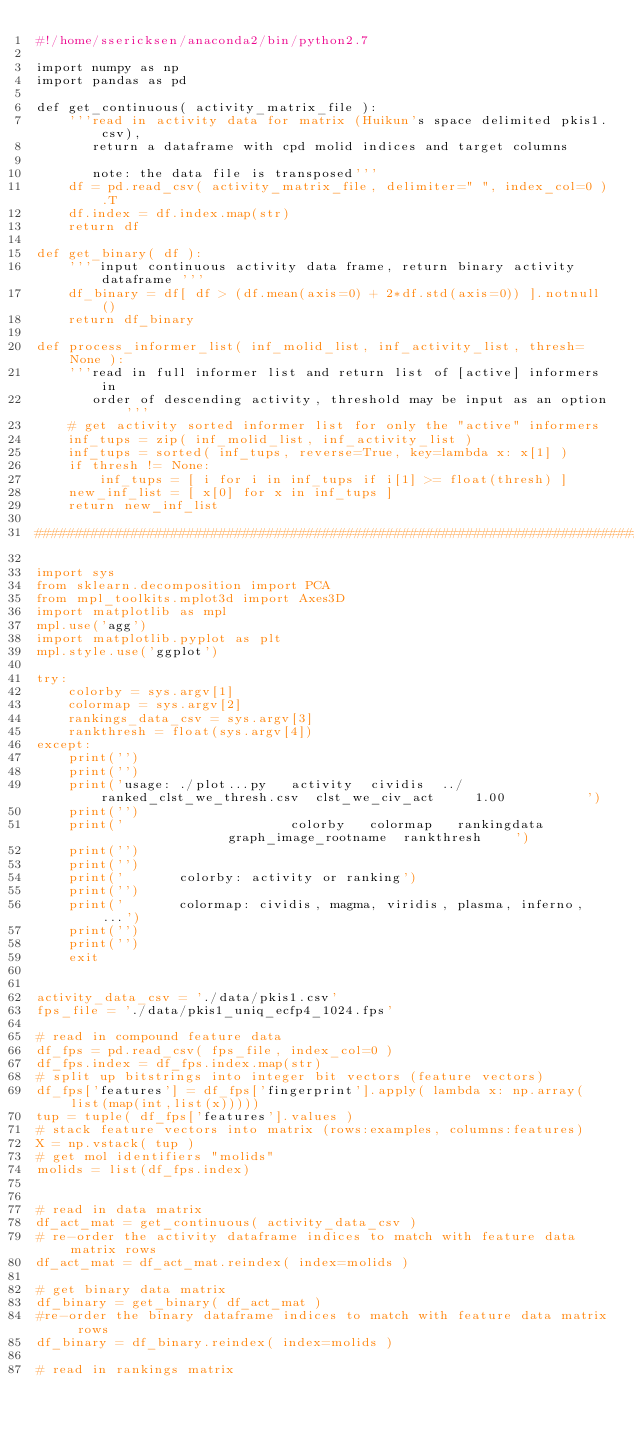Convert code to text. <code><loc_0><loc_0><loc_500><loc_500><_Python_>#!/home/ssericksen/anaconda2/bin/python2.7

import numpy as np
import pandas as pd

def get_continuous( activity_matrix_file ):
    '''read in activity data for matrix (Huikun's space delimited pkis1.csv),
       return a dataframe with cpd molid indices and target columns

       note: the data file is transposed'''
    df = pd.read_csv( activity_matrix_file, delimiter=" ", index_col=0 ).T
    df.index = df.index.map(str)
    return df

def get_binary( df ):
    ''' input continuous activity data frame, return binary activity dataframe '''
    df_binary = df[ df > (df.mean(axis=0) + 2*df.std(axis=0)) ].notnull()
    return df_binary

def process_informer_list( inf_molid_list, inf_activity_list, thresh=None ):
    '''read in full informer list and return list of [active] informers in
       order of descending activity, threshold may be input as an option'''
    # get activity sorted informer list for only the "active" informers
    inf_tups = zip( inf_molid_list, inf_activity_list )
    inf_tups = sorted( inf_tups, reverse=True, key=lambda x: x[1] )
    if thresh != None:
        inf_tups = [ i for i in inf_tups if i[1] >= float(thresh) ]
    new_inf_list = [ x[0] for x in inf_tups ]
    return new_inf_list 

###################################################################################

import sys
from sklearn.decomposition import PCA
from mpl_toolkits.mplot3d import Axes3D
import matplotlib as mpl
mpl.use('agg')
import matplotlib.pyplot as plt
mpl.style.use('ggplot')

try:
    colorby = sys.argv[1]
    colormap = sys.argv[2]
    rankings_data_csv = sys.argv[3]
    rankthresh = float(sys.argv[4])
except:
    print('')
    print('')
    print('usage: ./plot...py   activity  cividis  ../ranked_clst_we_thresh.csv  clst_we_civ_act     1.00          ')
    print('')
    print('                     colorby   colormap   rankingdata                 graph_image_rootname  rankthresh    ')
    print('')
    print('')
    print('       colorby: activity or ranking')
    print('')
    print('       colormap: cividis, magma, viridis, plasma, inferno, ...')
    print('')
    print('')
    exit


activity_data_csv = './data/pkis1.csv'
fps_file = './data/pkis1_uniq_ecfp4_1024.fps'

# read in compound feature data
df_fps = pd.read_csv( fps_file, index_col=0 )
df_fps.index = df_fps.index.map(str)
# split up bitstrings into integer bit vectors (feature vectors)
df_fps['features'] = df_fps['fingerprint'].apply( lambda x: np.array(list(map(int,list(x)))))
tup = tuple( df_fps['features'].values )
# stack feature vectors into matrix (rows:examples, columns:features)
X = np.vstack( tup )
# get mol identifiers "molids"
molids = list(df_fps.index)


# read in data matrix
df_act_mat = get_continuous( activity_data_csv )
# re-order the activity dataframe indices to match with feature data matrix rows
df_act_mat = df_act_mat.reindex( index=molids )

# get binary data matrix
df_binary = get_binary( df_act_mat )
#re-order the binary dataframe indices to match with feature data matrix rows
df_binary = df_binary.reindex( index=molids )

# read in rankings matrix</code> 